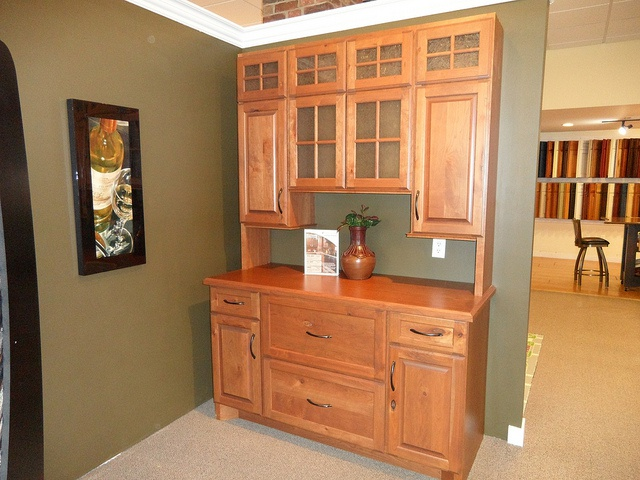Describe the objects in this image and their specific colors. I can see book in brown, maroon, and tan tones, book in brown, maroon, and black tones, bottle in brown, olive, tan, and beige tones, potted plant in brown, gray, maroon, and olive tones, and chair in brown, maroon, and orange tones in this image. 